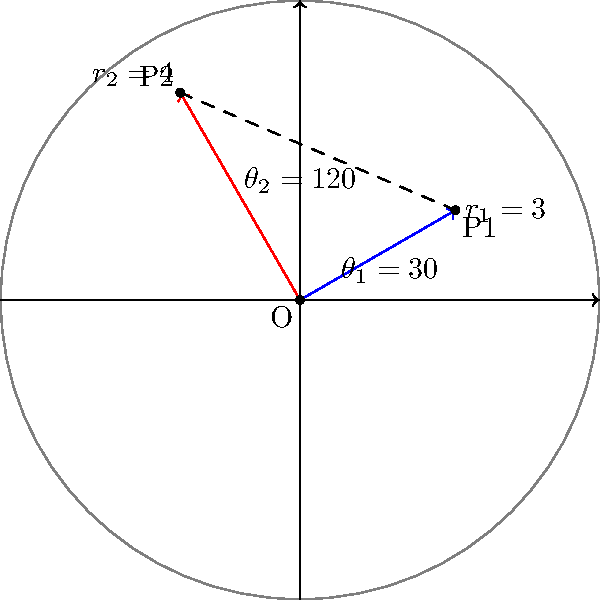During a military exercise, you need to calculate the distance between two observation posts. Post 1 is located 3 km from the command center at an angle of 30° from the reference line. Post 2 is 4 km from the command center at an angle of 120°. Using polar coordinates, calculate the distance between the two observation posts to the nearest tenth of a kilometer. To solve this problem, we'll use the law of cosines for polar coordinates:

1) Let's define our variables:
   $r_1 = 3$ km (distance to Post 1)
   $r_2 = 4$ km (distance to Post 2)
   $\theta_1 = 30°$
   $\theta_2 = 120°$

2) The angle between the two positions is:
   $\theta = \theta_2 - \theta_1 = 120° - 30° = 90°$

3) The law of cosines states:
   $d^2 = r_1^2 + r_2^2 - 2r_1r_2 \cos(\theta)$

4) Substituting our values:
   $d^2 = 3^2 + 4^2 - 2(3)(4)\cos(90°)$

5) Simplify:
   $d^2 = 9 + 16 - 24\cos(90°)$
   $d^2 = 25 - 24(0)$ (since $\cos(90°) = 0$)
   $d^2 = 25$

6) Take the square root of both sides:
   $d = \sqrt{25} = 5$

Therefore, the distance between the two observation posts is 5 km.
Answer: 5 km 